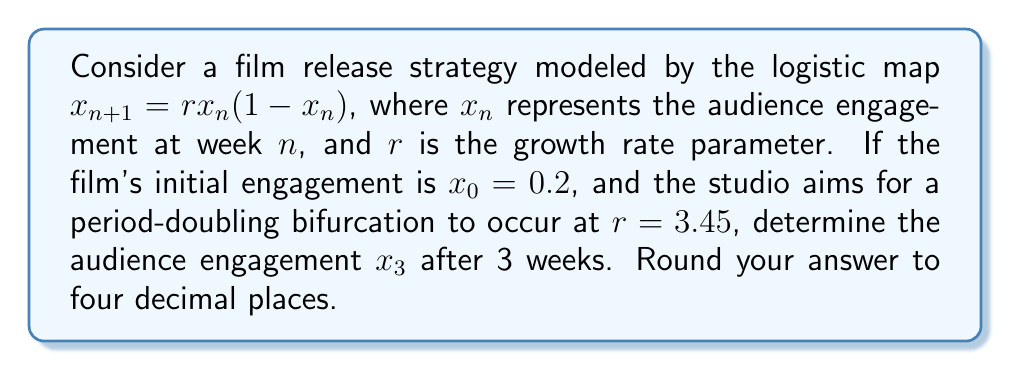Give your solution to this math problem. To solve this problem, we'll follow these steps:

1) The logistic map is given by $x_{n+1} = rx_n(1-x_n)$

2) We're given $x_0 = 0.2$ and $r = 3.45$

3) Let's calculate $x_1$:
   $x_1 = 3.45 \cdot 0.2 \cdot (1-0.2) = 3.45 \cdot 0.2 \cdot 0.8 = 0.552$

4) Now, let's calculate $x_2$:
   $x_2 = 3.45 \cdot 0.552 \cdot (1-0.552) = 3.45 \cdot 0.552 \cdot 0.448 = 0.8541696$

5) Finally, we can calculate $x_3$:
   $x_3 = 3.45 \cdot 0.8541696 \cdot (1-0.8541696)$
   $= 3.45 \cdot 0.8541696 \cdot 0.1458304$
   $= 0.4291632385$

6) Rounding to four decimal places: 0.4292

This result shows how the audience engagement fluctuates over the first three weeks, demonstrating the chaotic behavior of the logistic map at this growth rate.
Answer: 0.4292 